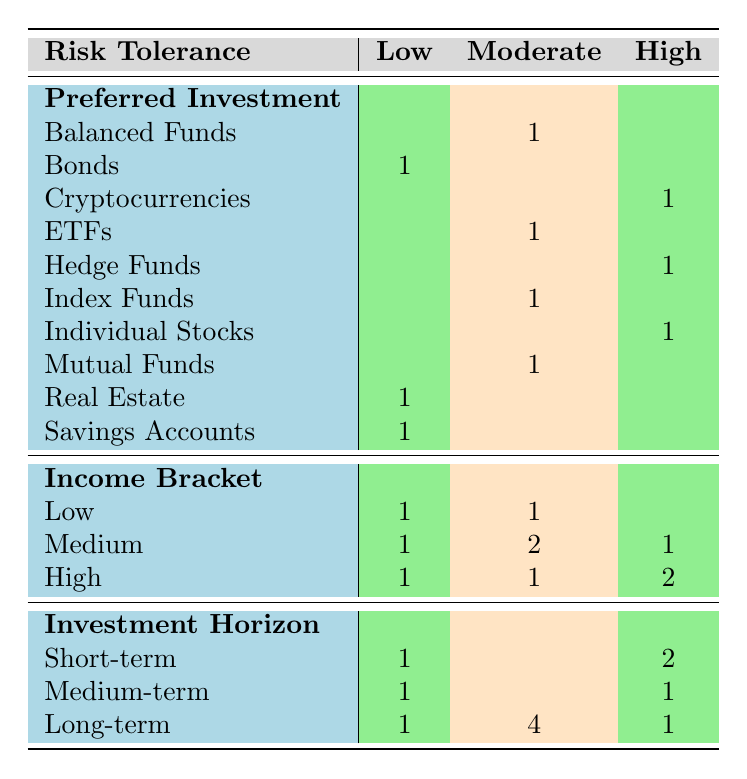What is the preferred investment strategy for individuals with low risk tolerance? From the table, the preferred investments for clients with low risk tolerance are "Bonds," "Real Estate," and "Savings Accounts." This is observed in the second row of the 'Preferred Investment' section under the 'Low' column.
Answer: Bonds, Real Estate, Savings Accounts How many clients are in the medium income bracket that prefer long-term investments? In the 'Income Bracket' section, we see that there are 2 clients in the medium income bracket who prefer long-term investments. This can be counted from the 'Medium' column under the 'Long-term' row.
Answer: 2 Which investment strategy is most preferred among clients with a high risk tolerance? The table shows that for clients with high risk tolerance, the preferred investments are "Cryptocurrencies," "Hedge Funds," and "Individual Stocks." Since there are three unique entries, we might say there is a preference for various strategies, with no single most preferred option.
Answer: Cryptocurrencies, Hedge Funds, Individual Stocks Are there more clients who prefer medium-term investment horizons than those who prefer short-term? In the table, there is 1 client preferring medium-term investments and 3 clients preferring short-term investments. Thus, there are more clients choosing short-term horizons than medium-term.
Answer: No What is the total number of clients who prefer investment in ETFs or Mutual Funds? The table indicates that there is 1 client preferring ETFs and 1 client preferring Mutual Funds. Adding these gives a total of 2 clients who prefer these investment types.
Answer: 2 How many clients are there in each income bracket with a high preference for long-term investments? Looking at the 'Income Bracket' section for clients who favor long-term investments, 1 client in the low bracket, 4 clients in the medium bracket, and 1 client in the high bracket are identified. This shows a count of 6 clients overall for long-term investments across income brackets.
Answer: 6 Which risk tolerance category has the most preferred investments listed? In the table, the risk tolerance of 'Moderate' shows 4 preferred investment entries (Balanced Funds, ETFs, Index Funds, Mutual Funds) which is more than the others in both low and high categories which only have 2 and 3 respectively.
Answer: Moderate Is it true that all clients with a high income bracket prefer medium-term investments? In the table, we can observe that there is one high-income client preferring long-term investments (Michael Brown) and one preferring medium-term investments (Amanda Martinez), showing that not all clients in the high-income bracket prefer medium-term investments.
Answer: No 